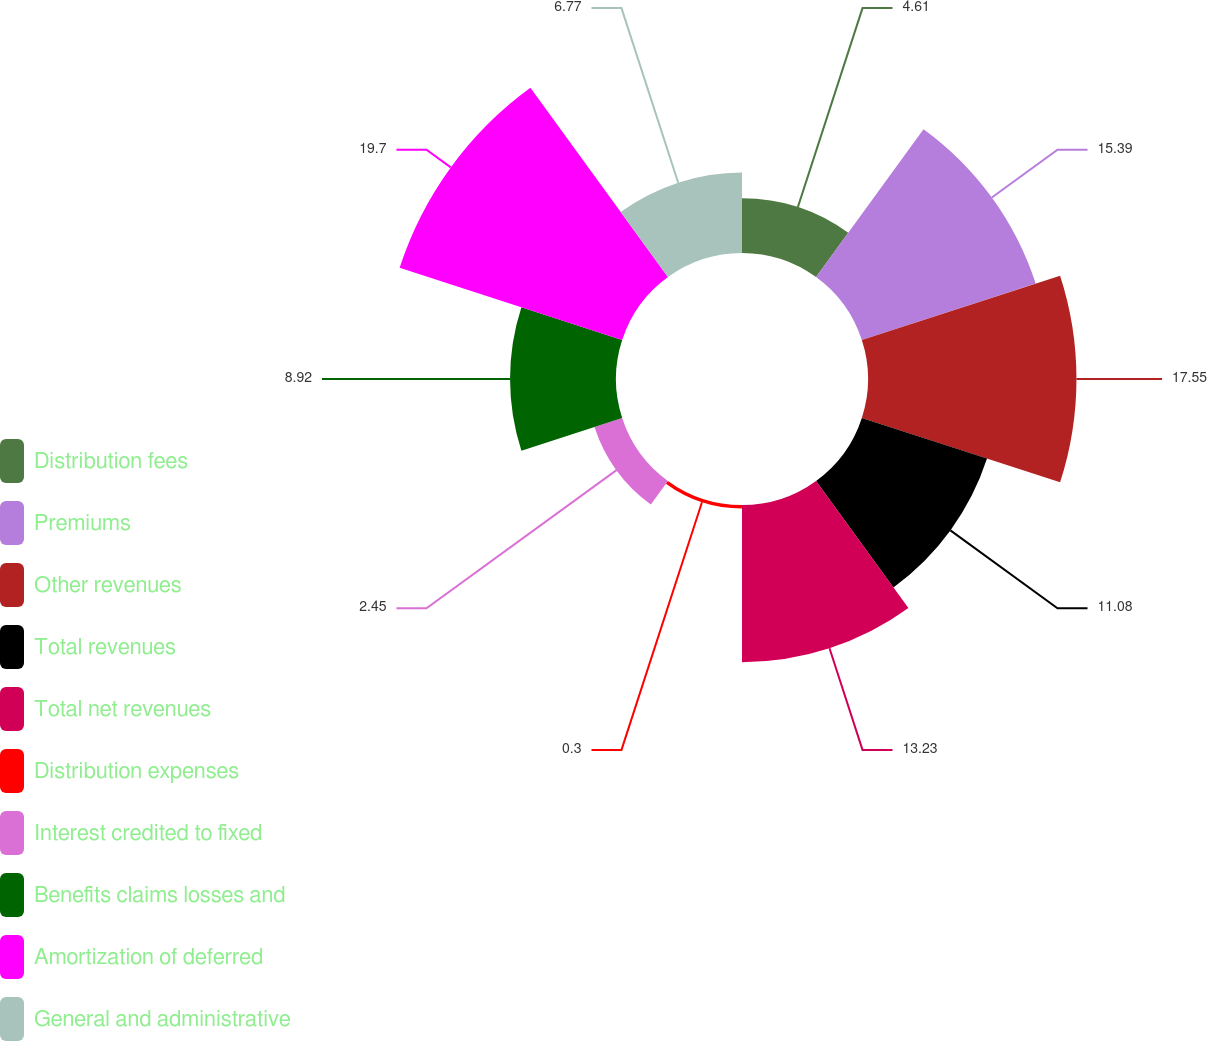Convert chart to OTSL. <chart><loc_0><loc_0><loc_500><loc_500><pie_chart><fcel>Distribution fees<fcel>Premiums<fcel>Other revenues<fcel>Total revenues<fcel>Total net revenues<fcel>Distribution expenses<fcel>Interest credited to fixed<fcel>Benefits claims losses and<fcel>Amortization of deferred<fcel>General and administrative<nl><fcel>4.61%<fcel>15.39%<fcel>17.55%<fcel>11.08%<fcel>13.23%<fcel>0.3%<fcel>2.45%<fcel>8.92%<fcel>19.7%<fcel>6.77%<nl></chart> 